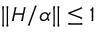Convert formula to latex. <formula><loc_0><loc_0><loc_500><loc_500>\| H / \alpha \| \leq 1</formula> 